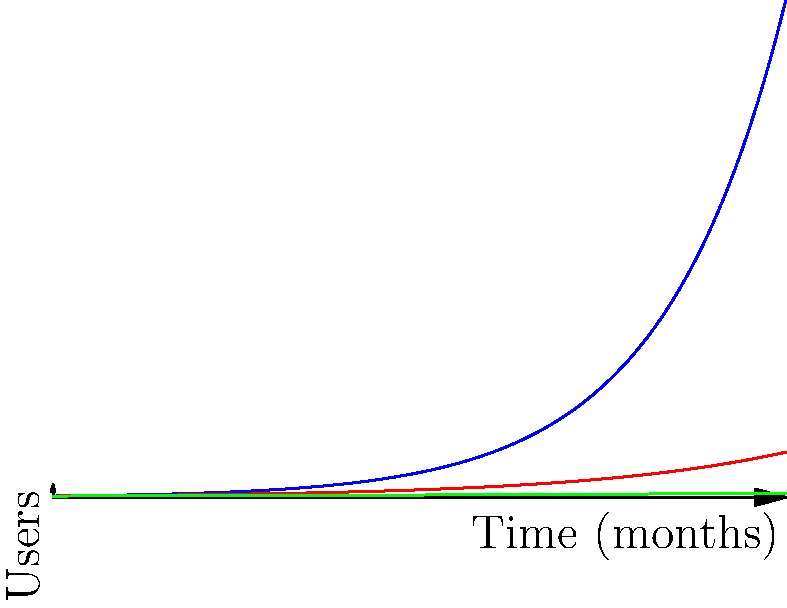A growth hacker is analyzing three different marketing strategies for a new app. The graph shows the projected user growth over 12 months for each strategy, starting with 1000 users. Strategy A follows the function $f(x)=1000e^{0.5x}$, Strategy B follows $g(x)=1000e^{0.3x}$, and Strategy C follows $h(x)=1000e^{0.1x}$, where $x$ is the number of months. After how many months will the difference in user count between Strategy A and Strategy B exceed 5000 users? To solve this problem, we need to find the point where the difference between Strategy A and Strategy B exceeds 5000 users. We can do this by setting up an inequality:

1. Set up the inequality:
   $$f(x) - g(x) > 5000$$

2. Substitute the functions:
   $$1000e^{0.5x} - 1000e^{0.3x} > 5000$$

3. Divide both sides by 1000:
   $$e^{0.5x} - e^{0.3x} > 5$$

4. This equation can't be solved algebraically, so we need to use numerical methods or graphing to find the solution.

5. Using a graphing calculator or computer software, we can plot $y = e^{0.5x} - e^{0.3x} - 5$ and find where it crosses the x-axis.

6. The solution is approximately x ≈ 7.69 months.

7. Since we're asked for the number of months after which the difference exceeds 5000, we need to round up to the next whole month.

Therefore, the difference in user count between Strategy A and Strategy B will exceed 5000 users after 8 months.
Answer: 8 months 